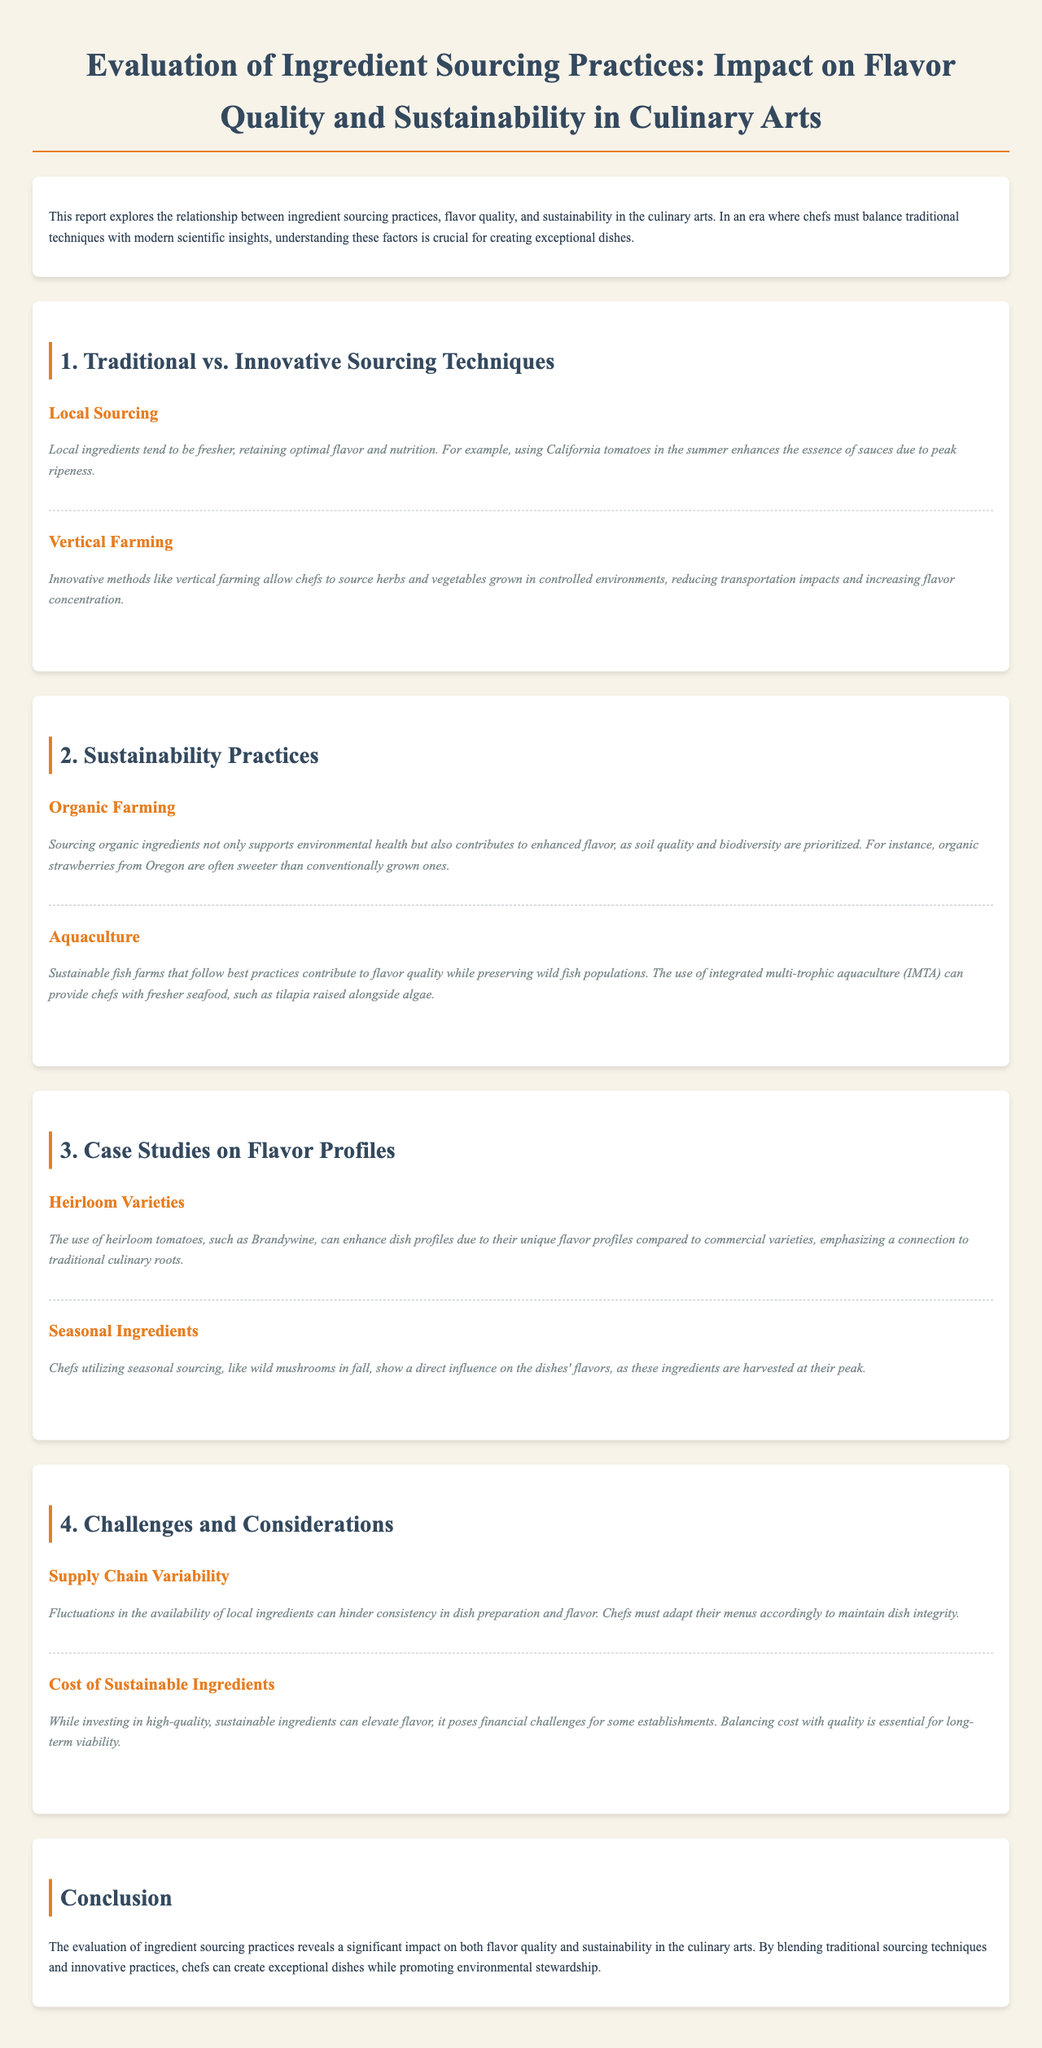What is the title of the report? The title of the report is provided at the top of the document, clearly stated.
Answer: Evaluation of Ingredient Sourcing Practices: Impact on Flavor Quality and Sustainability in Culinary Arts What is one traditional sourcing technique mentioned? The section on Traditional vs. Innovative Sourcing Techniques lists various practices, one of which is local sourcing.
Answer: Local Sourcing What is a benefit of vertical farming? The document states the impact of vertical farming on ingredient quality, specifically mentioning its benefits.
Answer: Flavor concentration Name one sustainable farming practice highlighted in the report. The section on Sustainability Practices details various methods, including organic farming.
Answer: Organic Farming What is a specific example of seasonal sourcing mentioned? The report includes an example of seasonal ingredients and specifies wild mushrooms in fall.
Answer: Wild mushrooms What is a challenge associated with supply chain variability? The report outlines challenges and considerations, including issues related to consistency in dish preparation.
Answer: Consistency What type of ingredient is suggested for enhanced flavor from organic practices? The document describes the flavor quality of organic ingredients, citing strawberries as a specific example.
Answer: Strawberries What is the conclusion of the report? The conclusion summarizes the findings regarding ingredient sourcing practices and their significance in culinary arts.
Answer: Significant impact on both flavor quality and sustainability What is one financial challenge mentioned for sustainable ingredients? The challenges and considerations section discusses costs associated with high-quality ingredients affecting businesses.
Answer: Financial challenges 